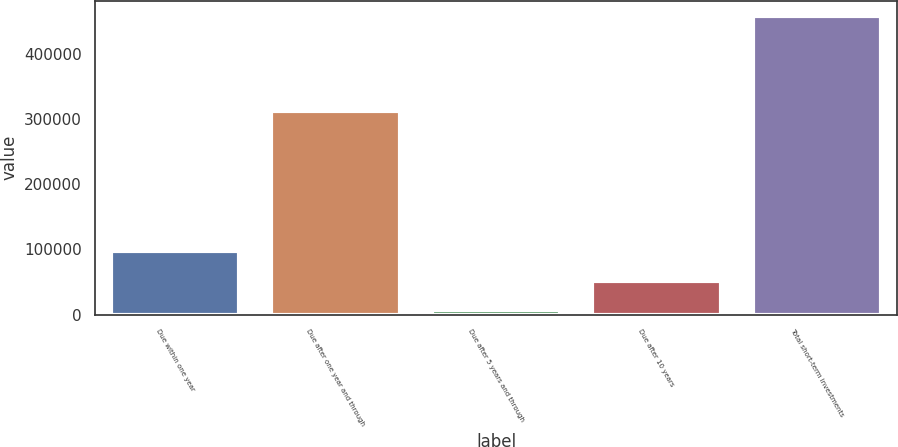Convert chart to OTSL. <chart><loc_0><loc_0><loc_500><loc_500><bar_chart><fcel>Due within one year<fcel>Due after one year and through<fcel>Due after 5 years and through<fcel>Due after 10 years<fcel>Total short-term investments<nl><fcel>96900.6<fcel>312096<fcel>6679<fcel>51789.8<fcel>457787<nl></chart> 